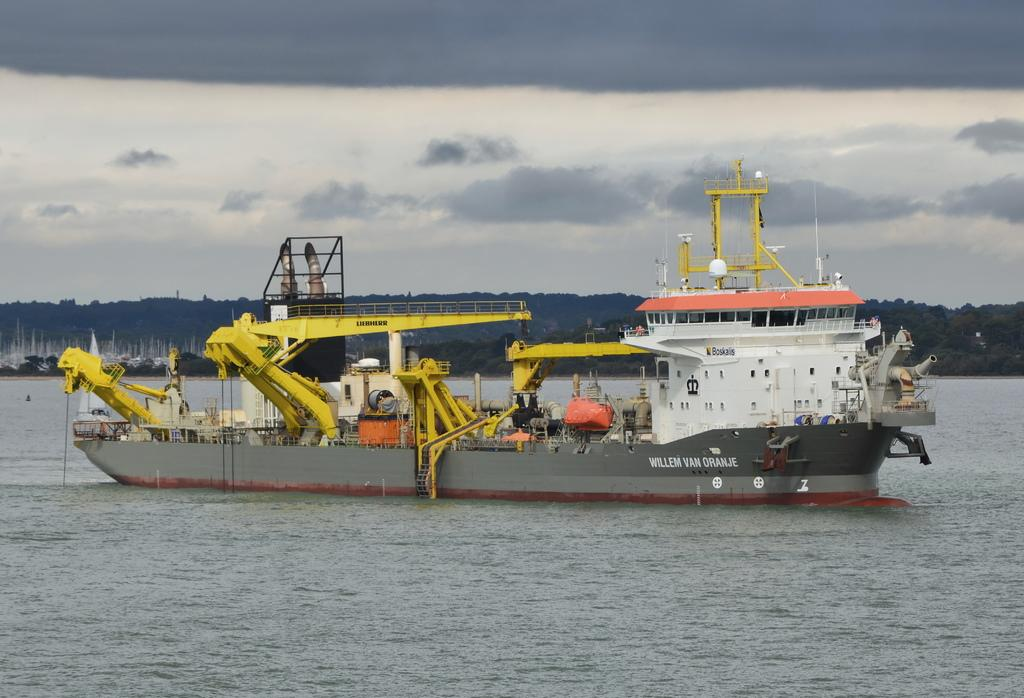What is the main subject of the image? The main subject of the image is a ship in the water. What can be seen in the water? There is a ship in the water. What is written in the image? There is text written in the image. What is visible in the background of the image? Clouds, the sky, and trees are visible in the background of the image. How many teeth can be seen on the ship in the image? There are no teeth present on the ship in the image. What type of cemetery is visible in the background of the image? There is no cemetery present in the image; it features a ship in the water with clouds, the sky, and trees in the background. 